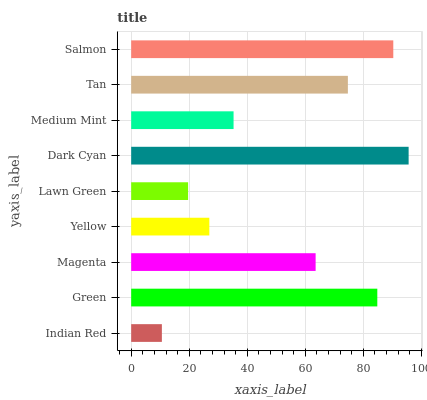Is Indian Red the minimum?
Answer yes or no. Yes. Is Dark Cyan the maximum?
Answer yes or no. Yes. Is Green the minimum?
Answer yes or no. No. Is Green the maximum?
Answer yes or no. No. Is Green greater than Indian Red?
Answer yes or no. Yes. Is Indian Red less than Green?
Answer yes or no. Yes. Is Indian Red greater than Green?
Answer yes or no. No. Is Green less than Indian Red?
Answer yes or no. No. Is Magenta the high median?
Answer yes or no. Yes. Is Magenta the low median?
Answer yes or no. Yes. Is Salmon the high median?
Answer yes or no. No. Is Yellow the low median?
Answer yes or no. No. 